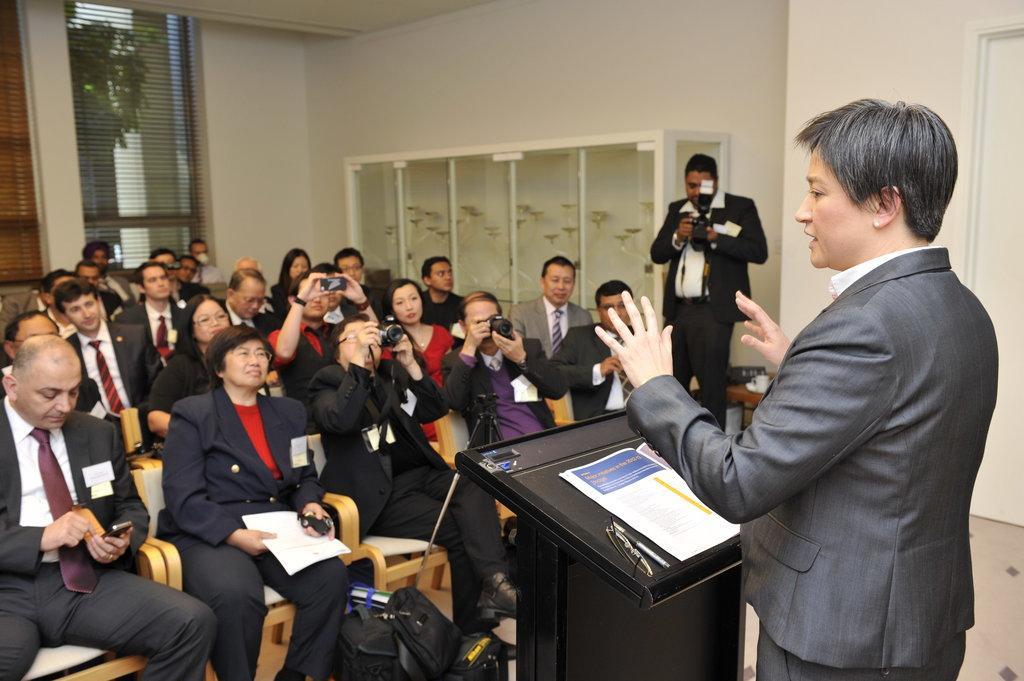Please provide a concise description of this image. In this image we can see a group of people sitting on chairs. Some people are holding devices in their hands. One woman is holding a paper. In the foreground of the image we can see some bags placed on the ground. On the right side of the image we can see two people standing. One person is holding the camera, we can also see a book, pen and spectacles placed on the podium. In the background, we can see some objects inside a glass door, windows and a tree. 